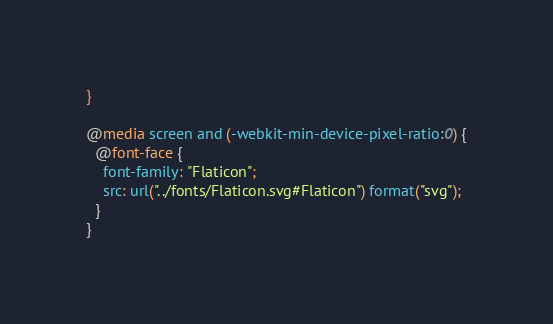<code> <loc_0><loc_0><loc_500><loc_500><_CSS_>}

@media screen and (-webkit-min-device-pixel-ratio:0) {
  @font-face {
    font-family: "Flaticon";
    src: url("../fonts/Flaticon.svg#Flaticon") format("svg");
  }
}</code> 